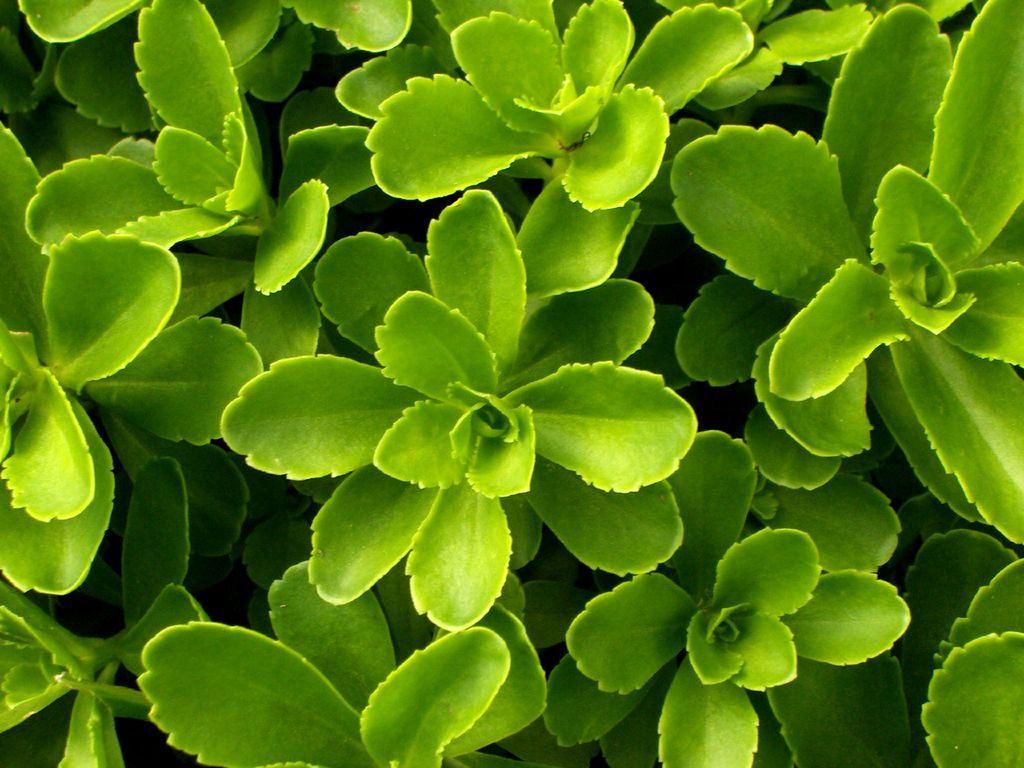Describe this image in one or two sentences. There are some plants with green leaves. 